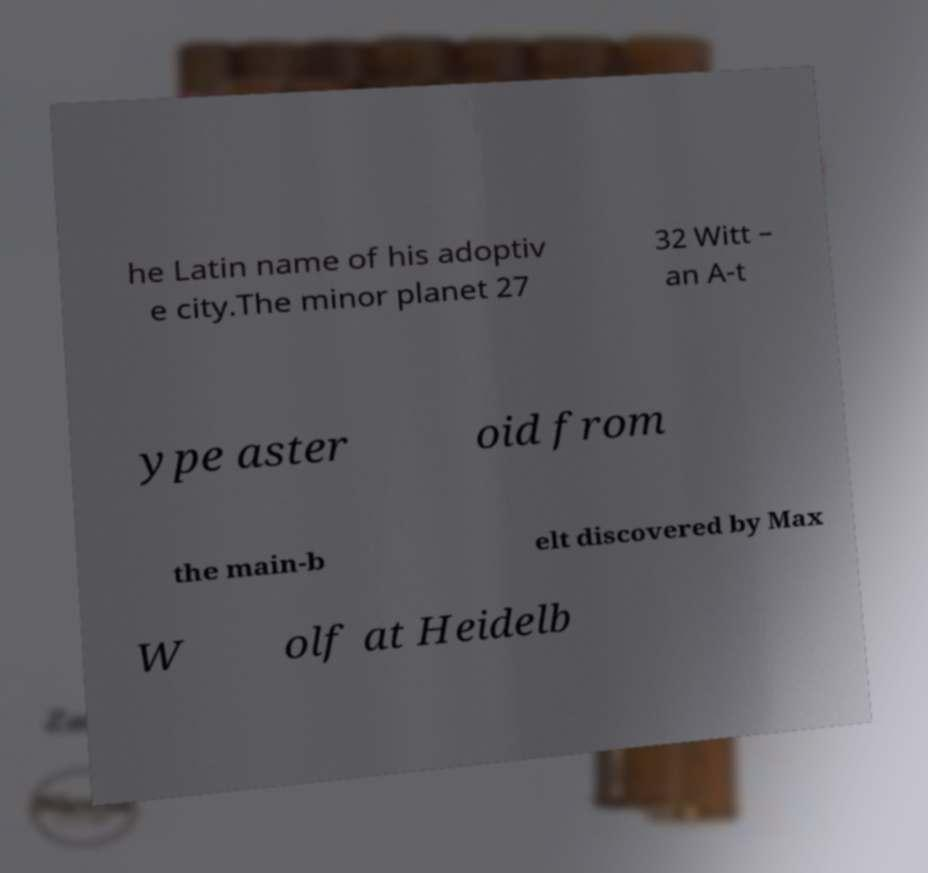Could you assist in decoding the text presented in this image and type it out clearly? he Latin name of his adoptiv e city.The minor planet 27 32 Witt – an A-t ype aster oid from the main-b elt discovered by Max W olf at Heidelb 